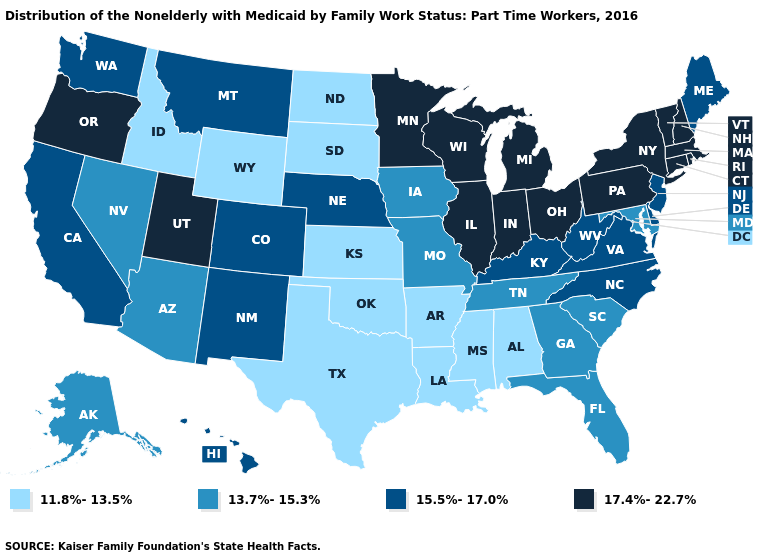Name the states that have a value in the range 11.8%-13.5%?
Answer briefly. Alabama, Arkansas, Idaho, Kansas, Louisiana, Mississippi, North Dakota, Oklahoma, South Dakota, Texas, Wyoming. Name the states that have a value in the range 17.4%-22.7%?
Keep it brief. Connecticut, Illinois, Indiana, Massachusetts, Michigan, Minnesota, New Hampshire, New York, Ohio, Oregon, Pennsylvania, Rhode Island, Utah, Vermont, Wisconsin. Name the states that have a value in the range 17.4%-22.7%?
Answer briefly. Connecticut, Illinois, Indiana, Massachusetts, Michigan, Minnesota, New Hampshire, New York, Ohio, Oregon, Pennsylvania, Rhode Island, Utah, Vermont, Wisconsin. What is the value of Kansas?
Concise answer only. 11.8%-13.5%. Name the states that have a value in the range 17.4%-22.7%?
Give a very brief answer. Connecticut, Illinois, Indiana, Massachusetts, Michigan, Minnesota, New Hampshire, New York, Ohio, Oregon, Pennsylvania, Rhode Island, Utah, Vermont, Wisconsin. Which states have the lowest value in the USA?
Be succinct. Alabama, Arkansas, Idaho, Kansas, Louisiana, Mississippi, North Dakota, Oklahoma, South Dakota, Texas, Wyoming. Among the states that border California , does Arizona have the lowest value?
Give a very brief answer. Yes. What is the lowest value in states that border Tennessee?
Write a very short answer. 11.8%-13.5%. Name the states that have a value in the range 11.8%-13.5%?
Write a very short answer. Alabama, Arkansas, Idaho, Kansas, Louisiana, Mississippi, North Dakota, Oklahoma, South Dakota, Texas, Wyoming. What is the value of Alaska?
Answer briefly. 13.7%-15.3%. Which states have the lowest value in the USA?
Answer briefly. Alabama, Arkansas, Idaho, Kansas, Louisiana, Mississippi, North Dakota, Oklahoma, South Dakota, Texas, Wyoming. Does Alaska have a higher value than Minnesota?
Keep it brief. No. What is the lowest value in the West?
Quick response, please. 11.8%-13.5%. What is the highest value in the USA?
Concise answer only. 17.4%-22.7%. Among the states that border Massachusetts , which have the lowest value?
Answer briefly. Connecticut, New Hampshire, New York, Rhode Island, Vermont. 